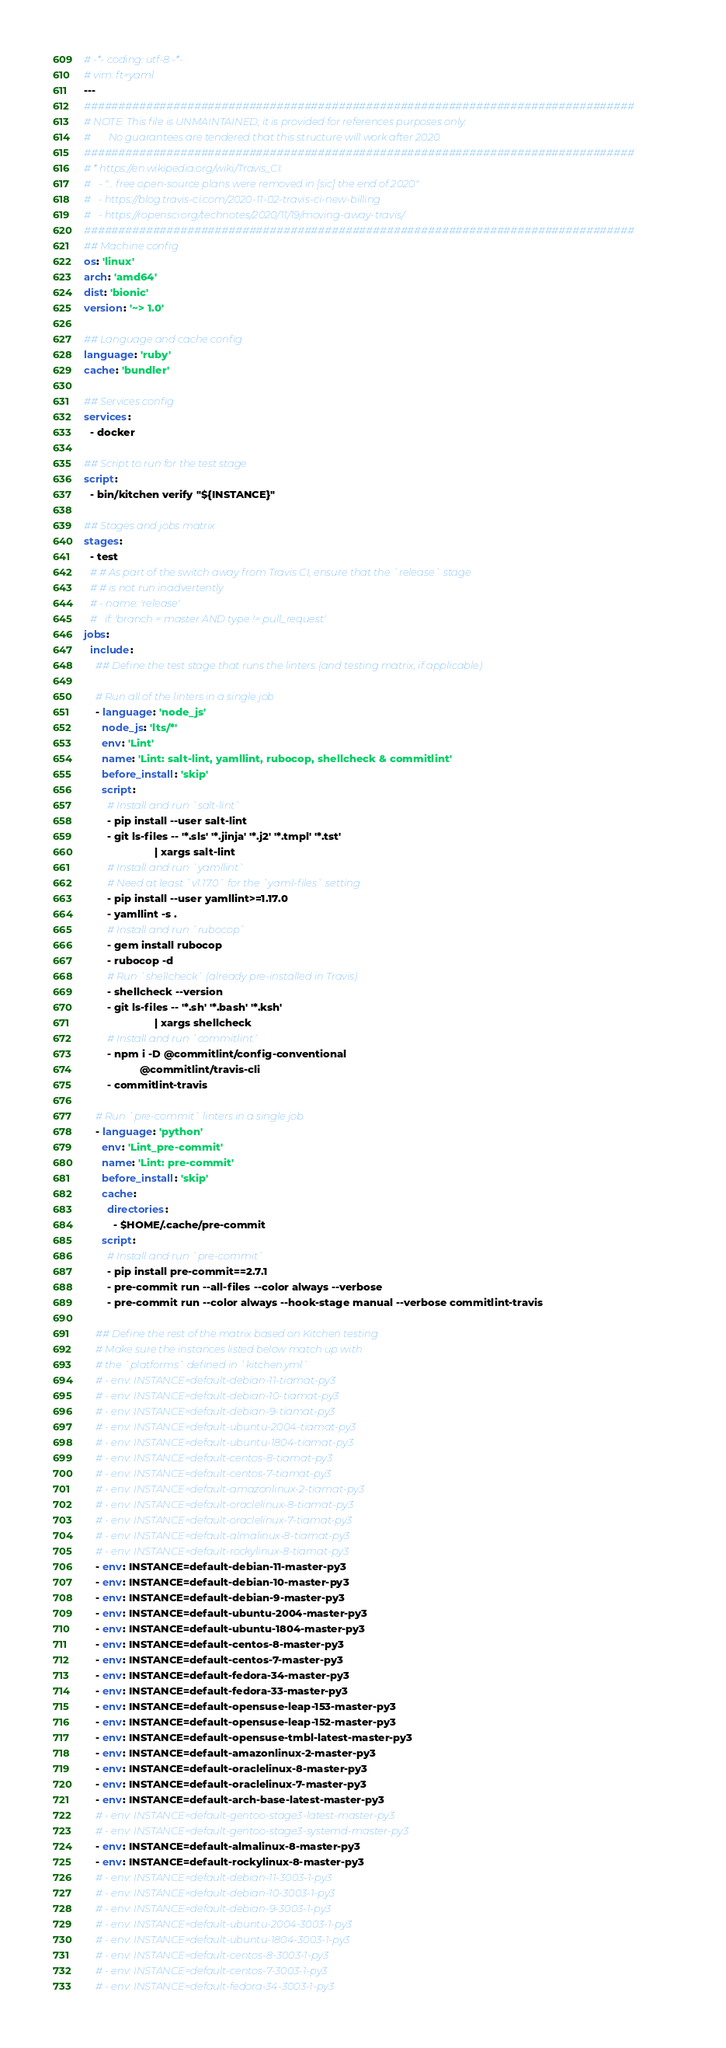<code> <loc_0><loc_0><loc_500><loc_500><_YAML_># -*- coding: utf-8 -*-
# vim: ft=yaml
---
################################################################################
# NOTE: This file is UNMAINTAINED; it is provided for references purposes only.
#       No guarantees are tendered that this structure will work after 2020.
################################################################################
# * https://en.wikipedia.org/wiki/Travis_CI:
#   - "... free open-source plans were removed in [sic] the end of 2020"
#   - https://blog.travis-ci.com/2020-11-02-travis-ci-new-billing
#   - https://ropensci.org/technotes/2020/11/19/moving-away-travis/
################################################################################
## Machine config
os: 'linux'
arch: 'amd64'
dist: 'bionic'
version: '~> 1.0'

## Language and cache config
language: 'ruby'
cache: 'bundler'

## Services config
services:
  - docker

## Script to run for the test stage
script:
  - bin/kitchen verify "${INSTANCE}"

## Stages and jobs matrix
stages:
  - test
  # # As part of the switch away from Travis CI, ensure that the `release` stage
  # # is not run inadvertently
  # - name: 'release'
  #   if: 'branch = master AND type != pull_request'
jobs:
  include:
    ## Define the test stage that runs the linters (and testing matrix, if applicable)

    # Run all of the linters in a single job
    - language: 'node_js'
      node_js: 'lts/*'
      env: 'Lint'
      name: 'Lint: salt-lint, yamllint, rubocop, shellcheck & commitlint'
      before_install: 'skip'
      script:
        # Install and run `salt-lint`
        - pip install --user salt-lint
        - git ls-files -- '*.sls' '*.jinja' '*.j2' '*.tmpl' '*.tst'
                        | xargs salt-lint
        # Install and run `yamllint`
        # Need at least `v1.17.0` for the `yaml-files` setting
        - pip install --user yamllint>=1.17.0
        - yamllint -s .
        # Install and run `rubocop`
        - gem install rubocop
        - rubocop -d
        # Run `shellcheck` (already pre-installed in Travis)
        - shellcheck --version
        - git ls-files -- '*.sh' '*.bash' '*.ksh'
                        | xargs shellcheck
        # Install and run `commitlint`
        - npm i -D @commitlint/config-conventional
                   @commitlint/travis-cli
        - commitlint-travis

    # Run `pre-commit` linters in a single job
    - language: 'python'
      env: 'Lint_pre-commit'
      name: 'Lint: pre-commit'
      before_install: 'skip'
      cache:
        directories:
          - $HOME/.cache/pre-commit
      script:
        # Install and run `pre-commit`
        - pip install pre-commit==2.7.1
        - pre-commit run --all-files --color always --verbose
        - pre-commit run --color always --hook-stage manual --verbose commitlint-travis

    ## Define the rest of the matrix based on Kitchen testing
    # Make sure the instances listed below match up with
    # the `platforms` defined in `kitchen.yml`
    # - env: INSTANCE=default-debian-11-tiamat-py3
    # - env: INSTANCE=default-debian-10-tiamat-py3
    # - env: INSTANCE=default-debian-9-tiamat-py3
    # - env: INSTANCE=default-ubuntu-2004-tiamat-py3
    # - env: INSTANCE=default-ubuntu-1804-tiamat-py3
    # - env: INSTANCE=default-centos-8-tiamat-py3
    # - env: INSTANCE=default-centos-7-tiamat-py3
    # - env: INSTANCE=default-amazonlinux-2-tiamat-py3
    # - env: INSTANCE=default-oraclelinux-8-tiamat-py3
    # - env: INSTANCE=default-oraclelinux-7-tiamat-py3
    # - env: INSTANCE=default-almalinux-8-tiamat-py3
    # - env: INSTANCE=default-rockylinux-8-tiamat-py3
    - env: INSTANCE=default-debian-11-master-py3
    - env: INSTANCE=default-debian-10-master-py3
    - env: INSTANCE=default-debian-9-master-py3
    - env: INSTANCE=default-ubuntu-2004-master-py3
    - env: INSTANCE=default-ubuntu-1804-master-py3
    - env: INSTANCE=default-centos-8-master-py3
    - env: INSTANCE=default-centos-7-master-py3
    - env: INSTANCE=default-fedora-34-master-py3
    - env: INSTANCE=default-fedora-33-master-py3
    - env: INSTANCE=default-opensuse-leap-153-master-py3
    - env: INSTANCE=default-opensuse-leap-152-master-py3
    - env: INSTANCE=default-opensuse-tmbl-latest-master-py3
    - env: INSTANCE=default-amazonlinux-2-master-py3
    - env: INSTANCE=default-oraclelinux-8-master-py3
    - env: INSTANCE=default-oraclelinux-7-master-py3
    - env: INSTANCE=default-arch-base-latest-master-py3
    # - env: INSTANCE=default-gentoo-stage3-latest-master-py3
    # - env: INSTANCE=default-gentoo-stage3-systemd-master-py3
    - env: INSTANCE=default-almalinux-8-master-py3
    - env: INSTANCE=default-rockylinux-8-master-py3
    # - env: INSTANCE=default-debian-11-3003-1-py3
    # - env: INSTANCE=default-debian-10-3003-1-py3
    # - env: INSTANCE=default-debian-9-3003-1-py3
    # - env: INSTANCE=default-ubuntu-2004-3003-1-py3
    # - env: INSTANCE=default-ubuntu-1804-3003-1-py3
    # - env: INSTANCE=default-centos-8-3003-1-py3
    # - env: INSTANCE=default-centos-7-3003-1-py3
    # - env: INSTANCE=default-fedora-34-3003-1-py3</code> 